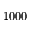Convert formula to latex. <formula><loc_0><loc_0><loc_500><loc_500>1 0 0 0</formula> 